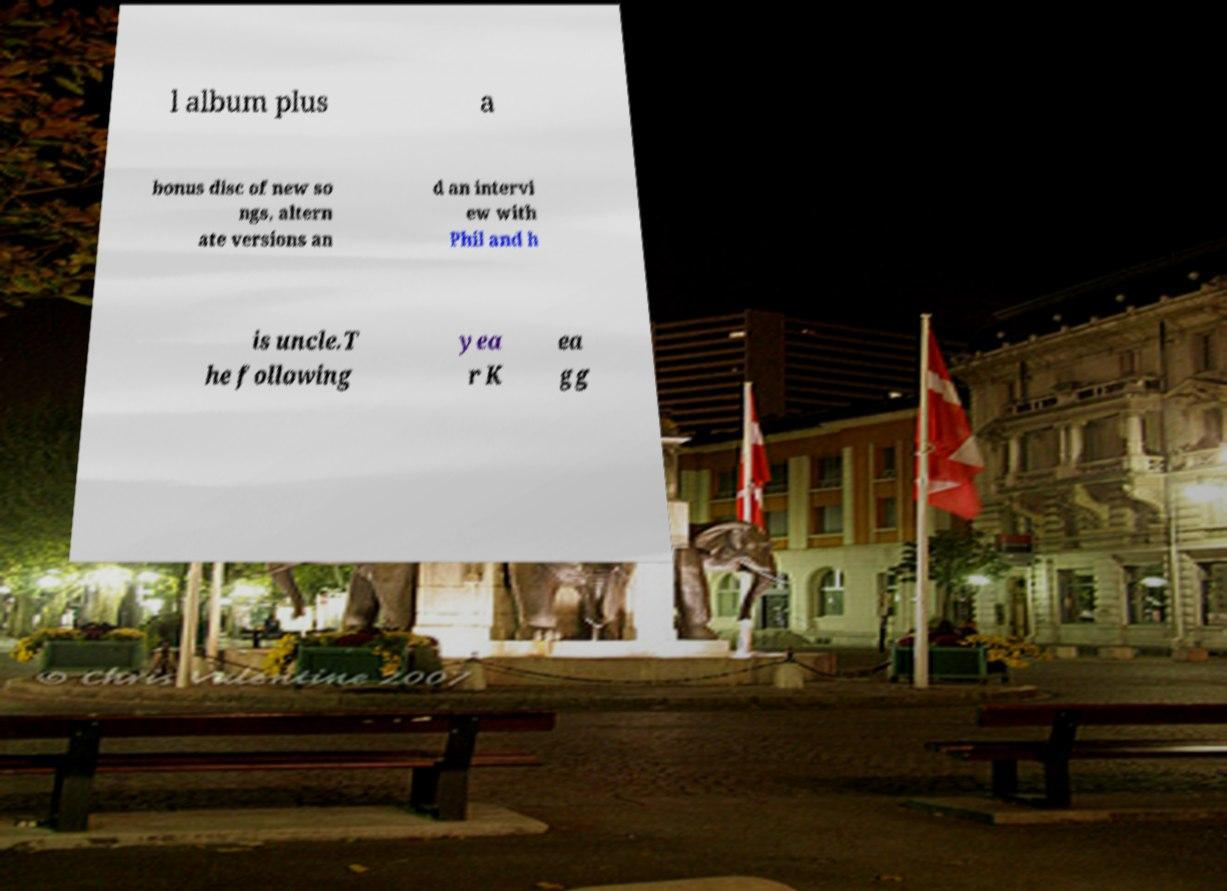Could you extract and type out the text from this image? l album plus a bonus disc of new so ngs, altern ate versions an d an intervi ew with Phil and h is uncle.T he following yea r K ea gg 